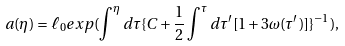Convert formula to latex. <formula><loc_0><loc_0><loc_500><loc_500>a ( \eta ) = \ell _ { 0 } e x p ( \int ^ { \eta } d \tau \{ C + \frac { 1 } { 2 } \int ^ { \tau } d \tau ^ { \prime } [ 1 + 3 \omega ( \tau ^ { \prime } ) ] \} ^ { - 1 } ) ,</formula> 